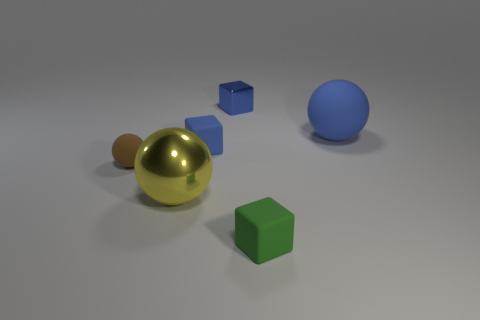Add 3 small brown rubber spheres. How many objects exist? 9 Subtract 0 gray spheres. How many objects are left? 6 Subtract all shiny objects. Subtract all blue spheres. How many objects are left? 3 Add 6 blue things. How many blue things are left? 9 Add 1 yellow spheres. How many yellow spheres exist? 2 